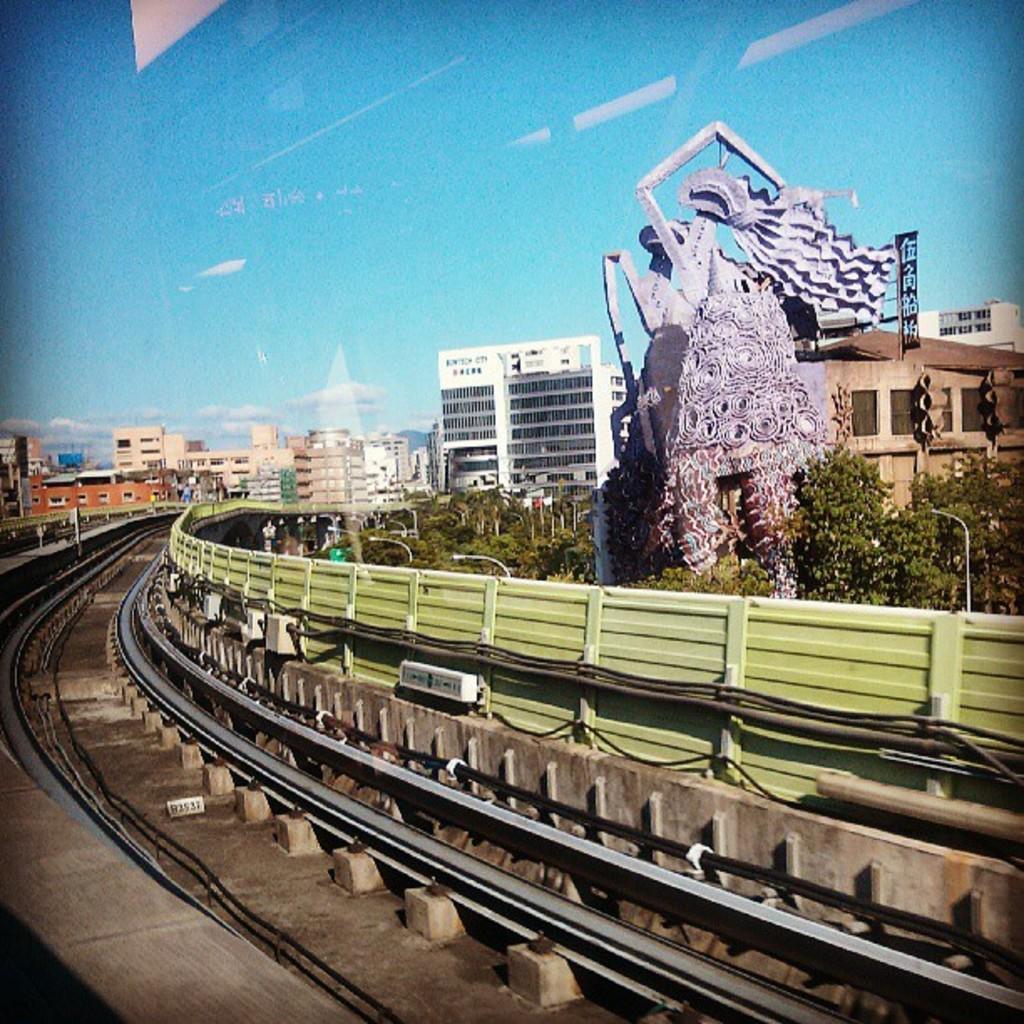Can you describe this image briefly? In the picture I can see a statue, fence, railway tracks, trees, street lights, buildings and some other objects. In the background I can see the sky. 